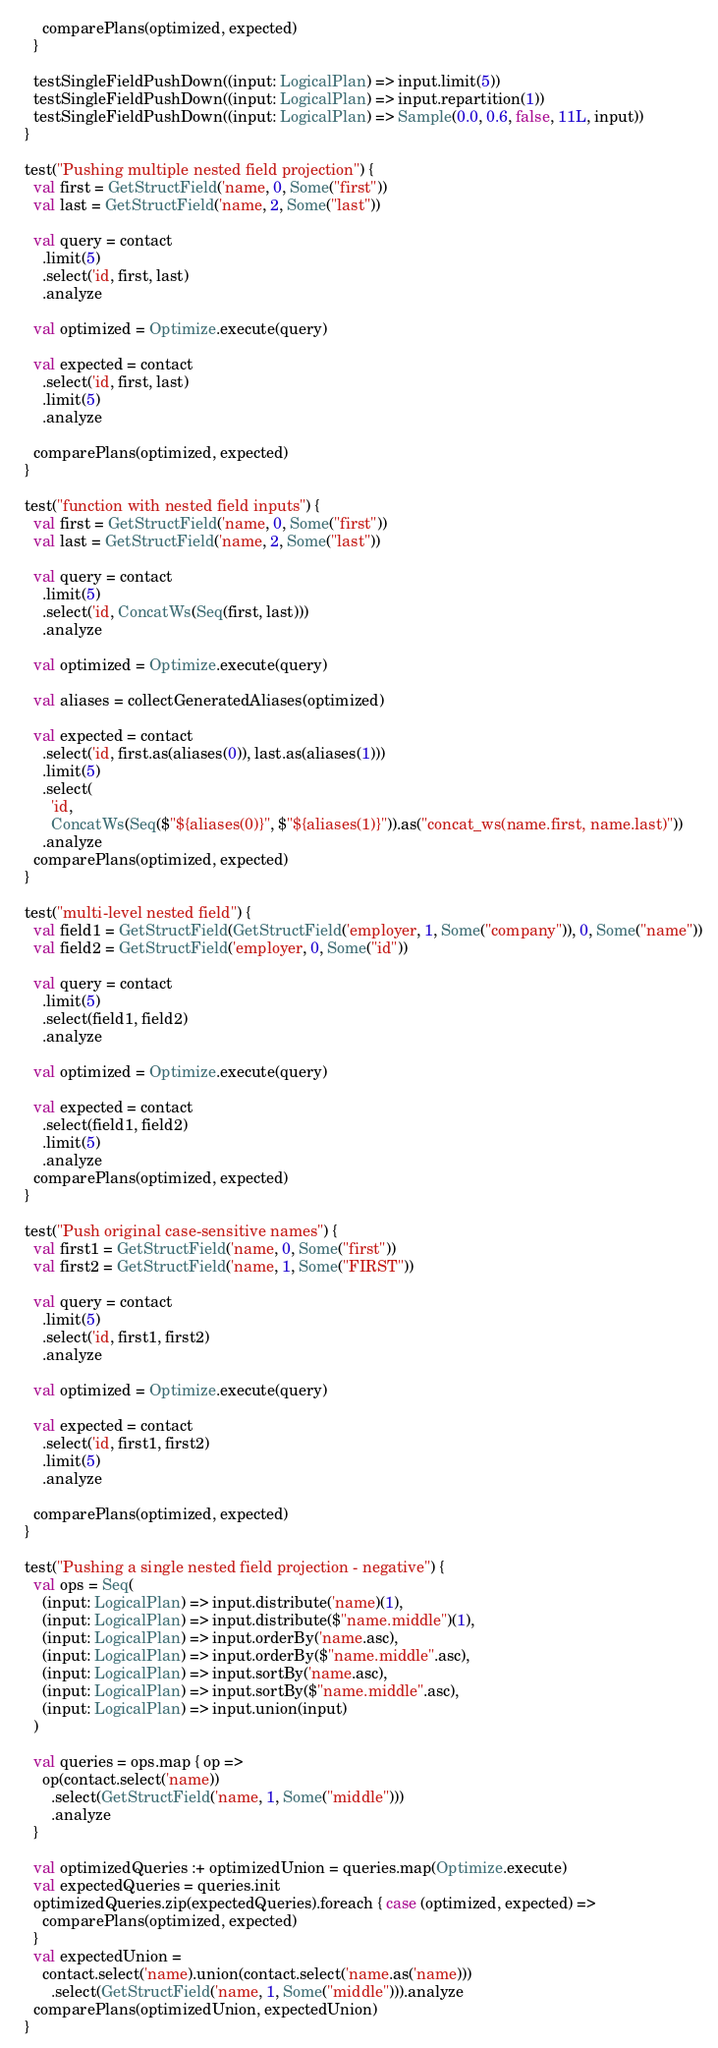Convert code to text. <code><loc_0><loc_0><loc_500><loc_500><_Scala_>      comparePlans(optimized, expected)
    }

    testSingleFieldPushDown((input: LogicalPlan) => input.limit(5))
    testSingleFieldPushDown((input: LogicalPlan) => input.repartition(1))
    testSingleFieldPushDown((input: LogicalPlan) => Sample(0.0, 0.6, false, 11L, input))
  }

  test("Pushing multiple nested field projection") {
    val first = GetStructField('name, 0, Some("first"))
    val last = GetStructField('name, 2, Some("last"))

    val query = contact
      .limit(5)
      .select('id, first, last)
      .analyze

    val optimized = Optimize.execute(query)

    val expected = contact
      .select('id, first, last)
      .limit(5)
      .analyze

    comparePlans(optimized, expected)
  }

  test("function with nested field inputs") {
    val first = GetStructField('name, 0, Some("first"))
    val last = GetStructField('name, 2, Some("last"))

    val query = contact
      .limit(5)
      .select('id, ConcatWs(Seq(first, last)))
      .analyze

    val optimized = Optimize.execute(query)

    val aliases = collectGeneratedAliases(optimized)

    val expected = contact
      .select('id, first.as(aliases(0)), last.as(aliases(1)))
      .limit(5)
      .select(
        'id,
        ConcatWs(Seq($"${aliases(0)}", $"${aliases(1)}")).as("concat_ws(name.first, name.last)"))
      .analyze
    comparePlans(optimized, expected)
  }

  test("multi-level nested field") {
    val field1 = GetStructField(GetStructField('employer, 1, Some("company")), 0, Some("name"))
    val field2 = GetStructField('employer, 0, Some("id"))

    val query = contact
      .limit(5)
      .select(field1, field2)
      .analyze

    val optimized = Optimize.execute(query)

    val expected = contact
      .select(field1, field2)
      .limit(5)
      .analyze
    comparePlans(optimized, expected)
  }

  test("Push original case-sensitive names") {
    val first1 = GetStructField('name, 0, Some("first"))
    val first2 = GetStructField('name, 1, Some("FIRST"))

    val query = contact
      .limit(5)
      .select('id, first1, first2)
      .analyze

    val optimized = Optimize.execute(query)

    val expected = contact
      .select('id, first1, first2)
      .limit(5)
      .analyze

    comparePlans(optimized, expected)
  }

  test("Pushing a single nested field projection - negative") {
    val ops = Seq(
      (input: LogicalPlan) => input.distribute('name)(1),
      (input: LogicalPlan) => input.distribute($"name.middle")(1),
      (input: LogicalPlan) => input.orderBy('name.asc),
      (input: LogicalPlan) => input.orderBy($"name.middle".asc),
      (input: LogicalPlan) => input.sortBy('name.asc),
      (input: LogicalPlan) => input.sortBy($"name.middle".asc),
      (input: LogicalPlan) => input.union(input)
    )

    val queries = ops.map { op =>
      op(contact.select('name))
        .select(GetStructField('name, 1, Some("middle")))
        .analyze
    }

    val optimizedQueries :+ optimizedUnion = queries.map(Optimize.execute)
    val expectedQueries = queries.init
    optimizedQueries.zip(expectedQueries).foreach { case (optimized, expected) =>
      comparePlans(optimized, expected)
    }
    val expectedUnion =
      contact.select('name).union(contact.select('name.as('name)))
        .select(GetStructField('name, 1, Some("middle"))).analyze
    comparePlans(optimizedUnion, expectedUnion)
  }
</code> 